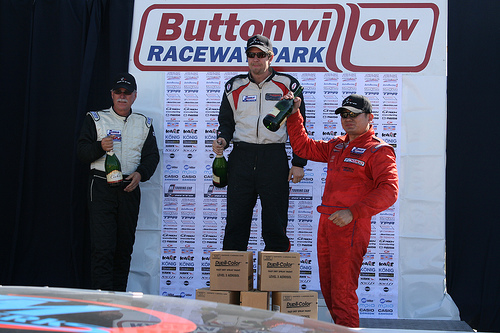<image>
Is there a man behind the boxes? Yes. From this viewpoint, the man is positioned behind the boxes, with the boxes partially or fully occluding the man. 